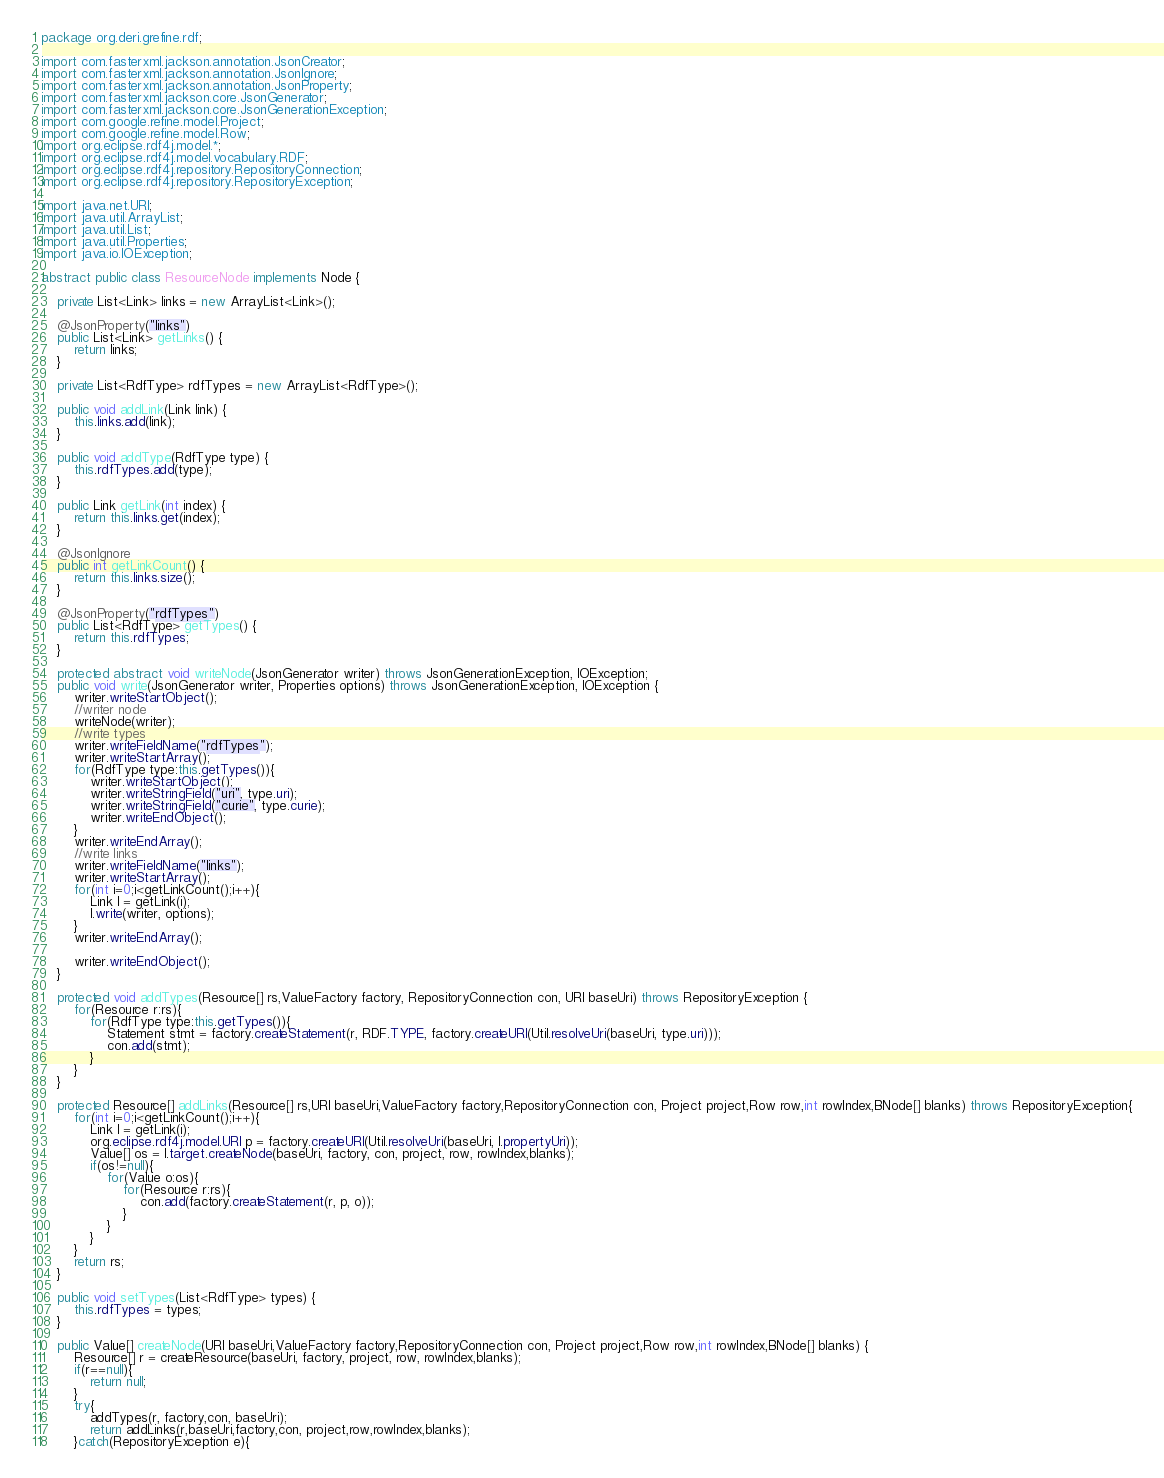Convert code to text. <code><loc_0><loc_0><loc_500><loc_500><_Java_>package org.deri.grefine.rdf;

import com.fasterxml.jackson.annotation.JsonCreator;
import com.fasterxml.jackson.annotation.JsonIgnore;
import com.fasterxml.jackson.annotation.JsonProperty;
import com.fasterxml.jackson.core.JsonGenerator;
import com.fasterxml.jackson.core.JsonGenerationException;
import com.google.refine.model.Project;
import com.google.refine.model.Row;
import org.eclipse.rdf4j.model.*;
import org.eclipse.rdf4j.model.vocabulary.RDF;
import org.eclipse.rdf4j.repository.RepositoryConnection;
import org.eclipse.rdf4j.repository.RepositoryException;

import java.net.URI;
import java.util.ArrayList;
import java.util.List;
import java.util.Properties;
import java.io.IOException;

abstract public class ResourceNode implements Node {

    private List<Link> links = new ArrayList<Link>();
    
    @JsonProperty("links")
    public List<Link> getLinks() {
		return links;
	}

	private List<RdfType> rdfTypes = new ArrayList<RdfType>();
    
    public void addLink(Link link) {
        this.links.add(link);
    }

    public void addType(RdfType type) {
        this.rdfTypes.add(type);
    }

    public Link getLink(int index) {
        return this.links.get(index);
    }

    @JsonIgnore
    public int getLinkCount() {
        return this.links.size();
    }

    @JsonProperty("rdfTypes")
    public List<RdfType> getTypes() {
        return this.rdfTypes;
    }

    protected abstract void writeNode(JsonGenerator writer) throws JsonGenerationException, IOException;
    public void write(JsonGenerator writer, Properties options) throws JsonGenerationException, IOException {
        writer.writeStartObject();
        //writer node
        writeNode(writer);
        //write types
        writer.writeFieldName("rdfTypes");
        writer.writeStartArray();
        for(RdfType type:this.getTypes()){
            writer.writeStartObject();
            writer.writeStringField("uri", type.uri);
            writer.writeStringField("curie", type.curie);
            writer.writeEndObject();
        }
        writer.writeEndArray();
        //write links
        writer.writeFieldName("links");
        writer.writeStartArray();
        for(int i=0;i<getLinkCount();i++){
            Link l = getLink(i);
            l.write(writer, options);
        }
        writer.writeEndArray();

        writer.writeEndObject();
    }

    protected void addTypes(Resource[] rs,ValueFactory factory, RepositoryConnection con, URI baseUri) throws RepositoryException {
    	for(Resource r:rs){
    		for(RdfType type:this.getTypes()){
    			Statement stmt = factory.createStatement(r, RDF.TYPE, factory.createURI(Util.resolveUri(baseUri, type.uri)));
    			con.add(stmt);
    		}
    	}
    }
    
    protected Resource[] addLinks(Resource[] rs,URI baseUri,ValueFactory factory,RepositoryConnection con, Project project,Row row,int rowIndex,BNode[] blanks) throws RepositoryException{
   		for(int i=0;i<getLinkCount();i++){
           	Link l = getLink(i);
           	org.eclipse.rdf4j.model.URI p = factory.createURI(Util.resolveUri(baseUri, l.propertyUri));
           	Value[] os = l.target.createNode(baseUri, factory, con, project, row, rowIndex,blanks);
           	if(os!=null){
           		for(Value o:os){
           			for(Resource r:rs){
           				con.add(factory.createStatement(r, p, o));
           			}
           		}
           	}
       	}
        return rs;
    }

    public void setTypes(List<RdfType> types) {
        this.rdfTypes = types;
    }
    
    public Value[] createNode(URI baseUri,ValueFactory factory,RepositoryConnection con, Project project,Row row,int rowIndex,BNode[] blanks) {
        Resource[] r = createResource(baseUri, factory, project, row, rowIndex,blanks);
        if(r==null){
            return null;
        }
        try{
        	addTypes(r, factory,con, baseUri);
        	return addLinks(r,baseUri,factory,con, project,row,rowIndex,blanks);
        }catch(RepositoryException e){</code> 